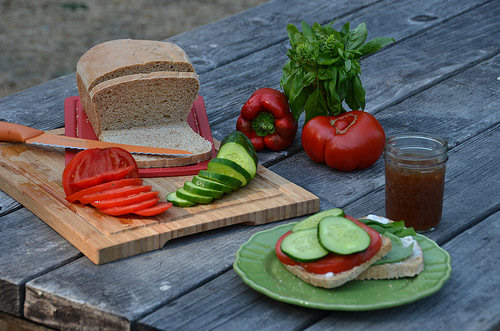<image>
Is there a plant on the table? Yes. Looking at the image, I can see the plant is positioned on top of the table, with the table providing support. Is there a jar on the plate? No. The jar is not positioned on the plate. They may be near each other, but the jar is not supported by or resting on top of the plate. Is the cucumber on the bread? No. The cucumber is not positioned on the bread. They may be near each other, but the cucumber is not supported by or resting on top of the bread. 